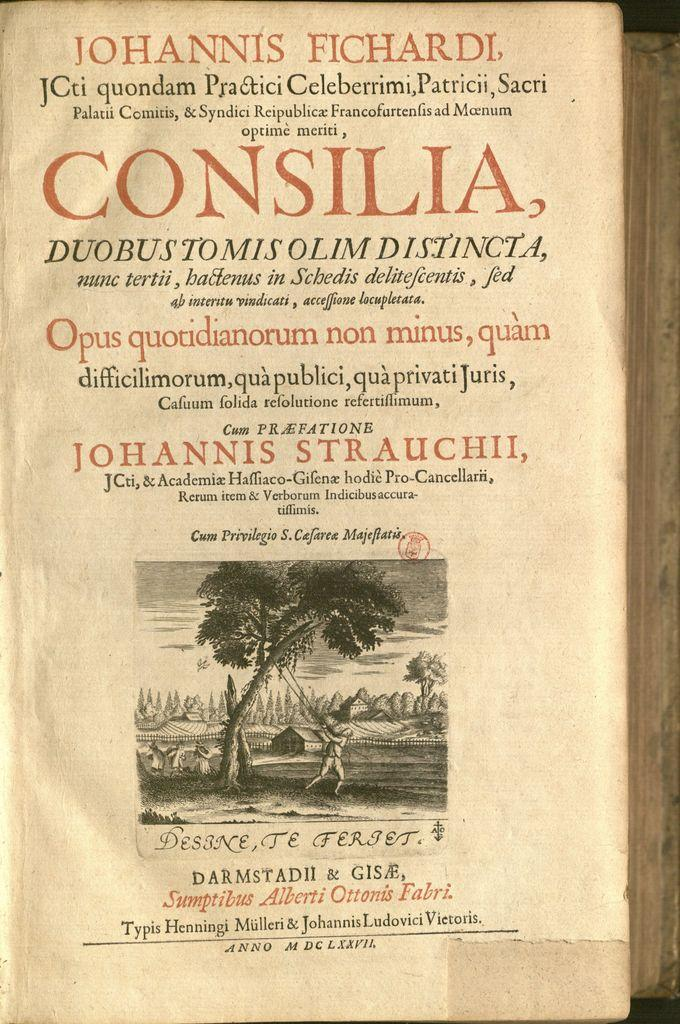What object can be seen in the image? There is a book in the image. What is featured on the book? The book has text and a picture. What type of meal is being prepared with the hammer and bucket in the image? There is no hammer, bucket, or meal present in the image; it only features a book with text and a picture. 